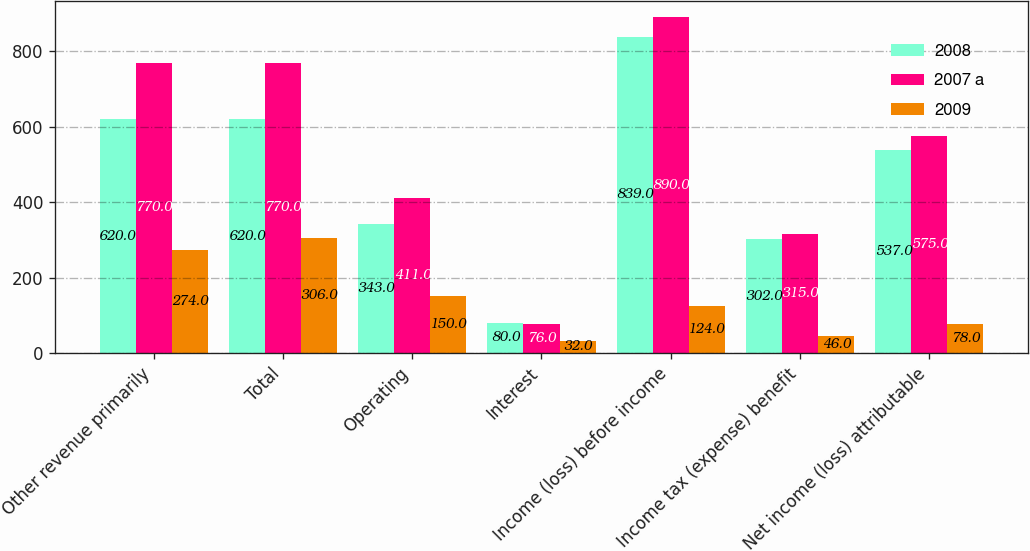Convert chart. <chart><loc_0><loc_0><loc_500><loc_500><stacked_bar_chart><ecel><fcel>Other revenue primarily<fcel>Total<fcel>Operating<fcel>Interest<fcel>Income (loss) before income<fcel>Income tax (expense) benefit<fcel>Net income (loss) attributable<nl><fcel>2008<fcel>620<fcel>620<fcel>343<fcel>80<fcel>839<fcel>302<fcel>537<nl><fcel>2007 a<fcel>770<fcel>770<fcel>411<fcel>76<fcel>890<fcel>315<fcel>575<nl><fcel>2009<fcel>274<fcel>306<fcel>150<fcel>32<fcel>124<fcel>46<fcel>78<nl></chart> 